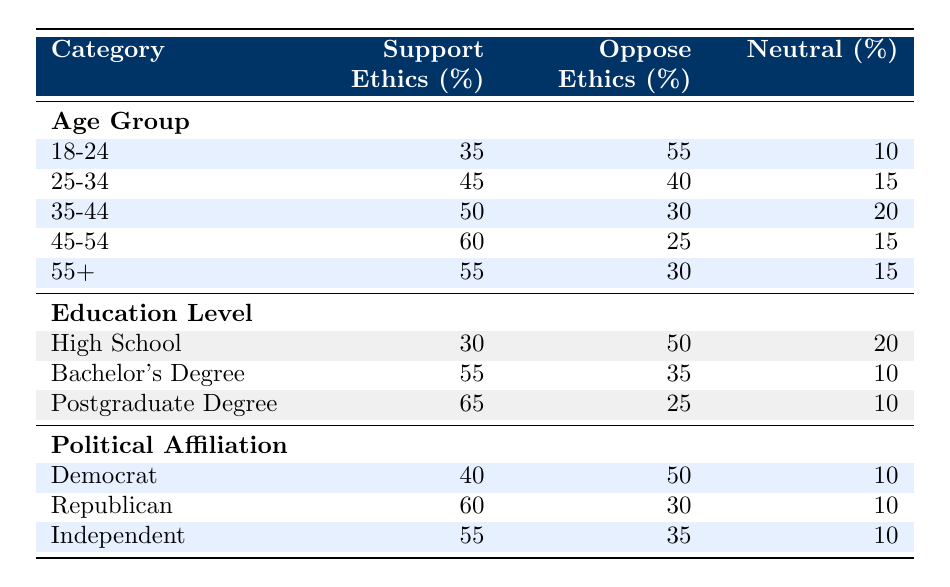What percentage of respondents aged 18-24 support ethics in lobbying? According to the table, the data shows that 35% of respondents in the age group 18-24 support ethics in lobbying.
Answer: 35% Which age group has the highest percentage of support for ethics in lobbying? By comparing the support percentages from each age group in the table, the age group 45-54 has the highest support at 60%.
Answer: 45-54 What is the difference in the percentage of support for ethics in lobbying between the 35-44 age group and those with a postgraduate degree? The support for ethics in lobbying for the 35-44 age group is 50% and for the postgraduate degree, it is 65%. The difference is 65% - 50% = 15%.
Answer: 15% Do a majority of respondents with a Bachelor's degree oppose ethics in lobbying? Looking at the table, 35% of respondents with a Bachelor's degree oppose ethics in lobbying, which does not constitute a majority as it's less than 50%.
Answer: No What is the average percentage of support for ethics in lobbying across all age groups? To find the average, add the support percentages for all age groups (35% + 45% + 50% + 60% + 55% = 245%) and divide by the number of age groups (5). The average is 245% / 5 = 49%.
Answer: 49% Which political affiliation has the lowest opposition to ethics in lobbying? From the data, the Republicans show 30% opposition, which is the lowest compared to 50% for Democrats and 35% for Independents.
Answer: Republican Is there a higher percentage of individuals with a postgraduate degree supporting ethics in lobbying compared to those aged 18-24? Yes, individuals with a postgraduate degree show 65% support while those aged 18-24 show only 35% support, making it true that the former percentage is higher.
Answer: Yes Which category has the highest neutrality regarding ethics in lobbying? The highest neutrality is found in the age group 35-44 with 20%. By comparing all categories, this is the most significant neutrality percentage present in the table.
Answer: 35-44 